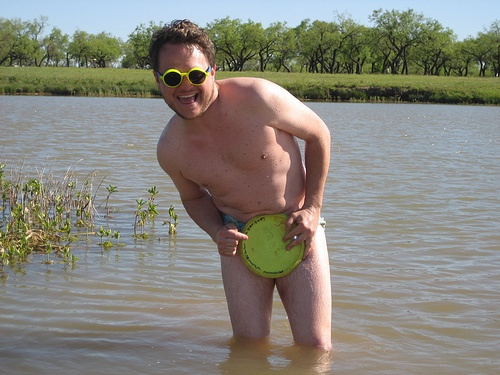Describe the objects in this image and their specific colors. I can see people in lightblue, brown, maroon, and olive tones and frisbee in lightblue, olive, maroon, and black tones in this image. 